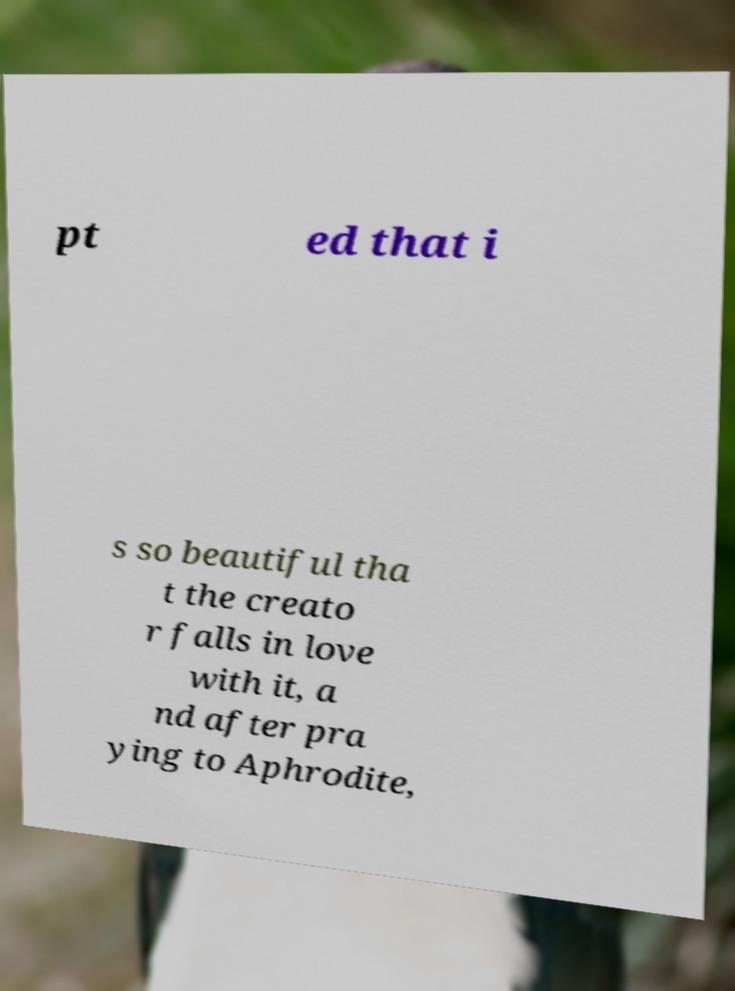Could you assist in decoding the text presented in this image and type it out clearly? pt ed that i s so beautiful tha t the creato r falls in love with it, a nd after pra ying to Aphrodite, 